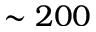<formula> <loc_0><loc_0><loc_500><loc_500>\sim 2 0 0</formula> 